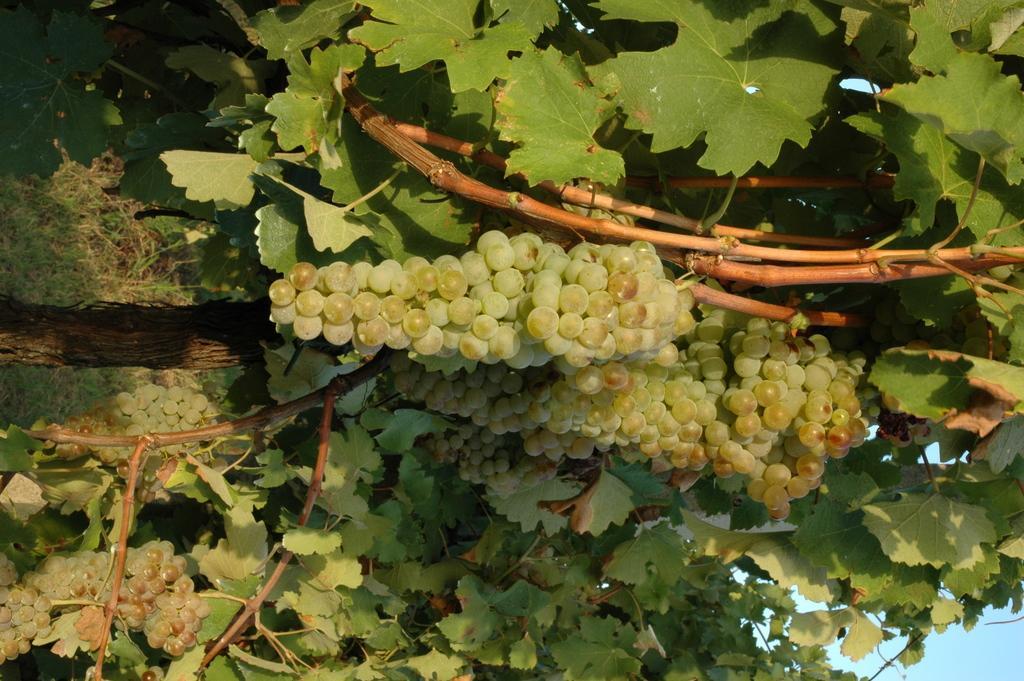Please provide a concise description of this image. In this image there are few trees visible, on which there are few bunch of grapes visible, in the bottom right there is the sky. 